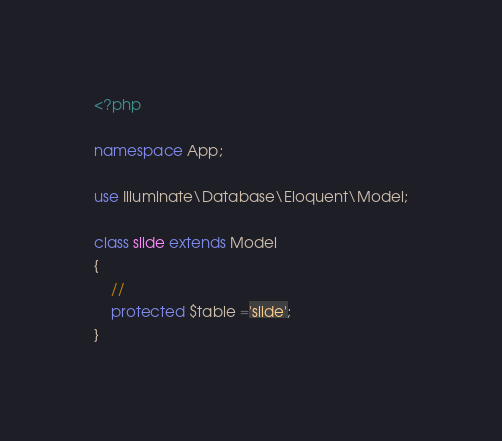Convert code to text. <code><loc_0><loc_0><loc_500><loc_500><_PHP_><?php

namespace App;

use Illuminate\Database\Eloquent\Model;

class slide extends Model
{
    //
    protected $table ='slide';
}
</code> 